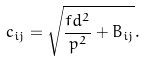Convert formula to latex. <formula><loc_0><loc_0><loc_500><loc_500>c _ { i j } = \sqrt { \frac { \L f d ^ { 2 } } { p ^ { 2 } } + B _ { i j } } .</formula> 